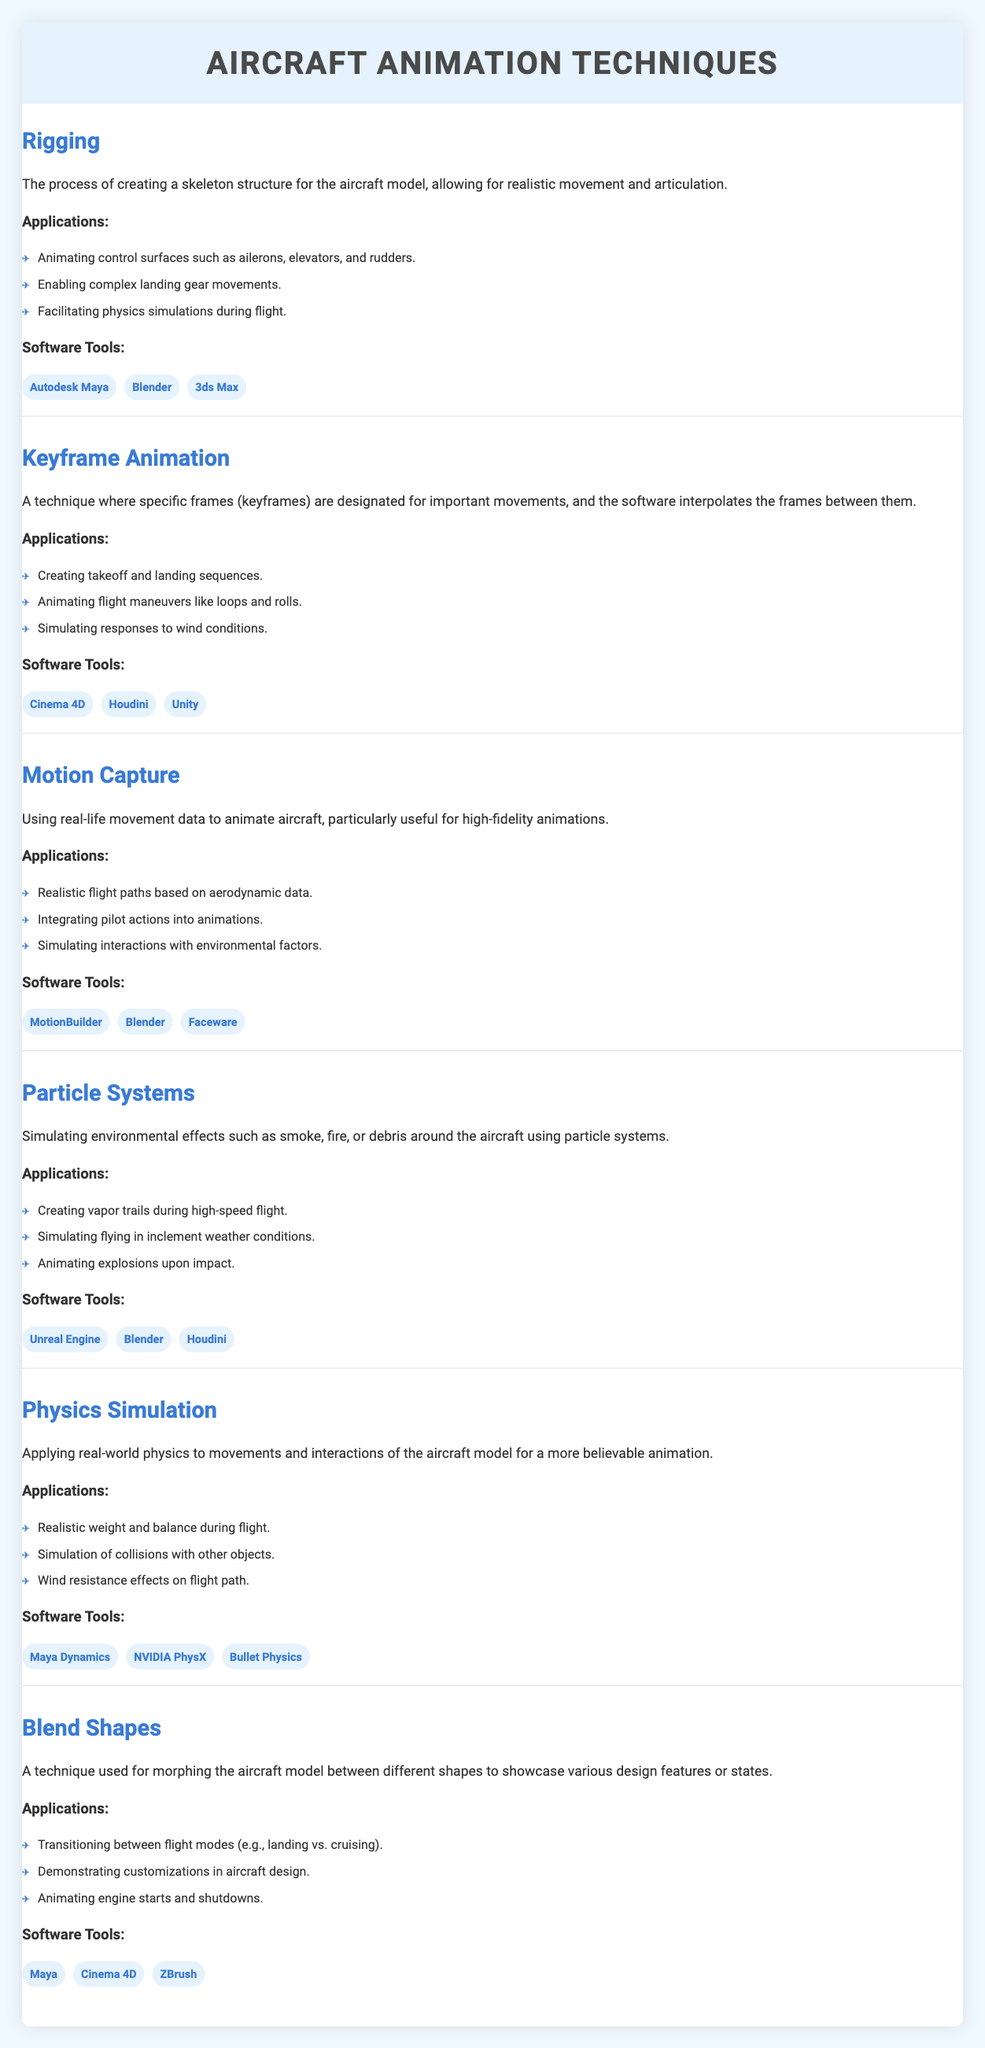What is the description of the technique "Rigging"? The description of "Rigging" is clearly stated in the table: it is "The process of creating a skeleton structure for the aircraft model, allowing for realistic movement and articulation."
Answer: The process of creating a skeleton structure for the aircraft model, allowing for realistic movement and articulation Which software tools are used for Particle Systems? The table lists the software tools under the "Particle Systems" technique. They are: "Unreal Engine," "Blender," and "Houdini."
Answer: Unreal Engine, Blender, Houdini Are there more applications for Keyframe Animation than for Rigging? The "Applications" section for Keyframe Animation lists three applications while Rigging also lists three applications. Therefore, the number of applications is equal, not more.
Answer: No How many techniques utilize Blender as a software tool? By examining the software tools across all techniques, Blender appears in "Rigging," "Motion Capture," "Particle Systems," and "Blend Shapes." This totals four techniques that utilize Blender.
Answer: Four What are the applications of Physics Simulation? The table outlines three applications under Physics Simulation: "Realistic weight and balance during flight," "Simulation of collisions with other objects," and "Wind resistance effects on flight path."
Answer: Realistic weight and balance during flight; Simulation of collisions with other objects; Wind resistance effects on flight path Is "Motion Capture" used for creating takeoff sequences? "Motion Capture" is focused on realistic flight paths, integrating pilot actions, and simulating environmental interactions, but does not mention takeoff sequences. Thus, it does not directly address creating takeoff sequences.
Answer: No Compare the number of applications in Blend Shapes with those in Motion Capture. Blend Shapes lists three applications while Motion Capture also lists three applications. Therefore, both techniques have an equal number of applications.
Answer: They are equal What is the common purpose of the Particle Systems and Motion Capture techniques? Both techniques are aimed at enhancing realism within animations. Particle Systems create environmental effects, while Motion Capture captures realistic movements, integrating real-life data into animations.
Answer: Enhancing realism within animations 